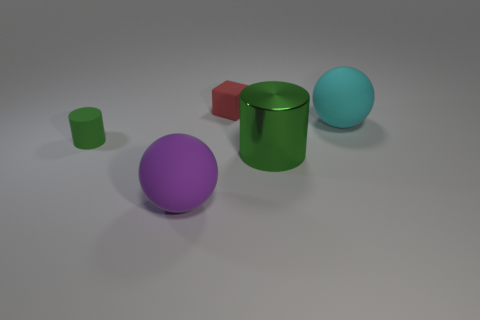Is the material of the tiny green cylinder the same as the big green thing?
Offer a very short reply. No. What number of blocks are either large gray rubber things or cyan things?
Offer a very short reply. 0. There is a green object that is to the left of the small object to the right of the rubber sphere that is to the left of the red thing; what size is it?
Your answer should be very brief. Small. The other object that is the same shape as the green matte object is what size?
Ensure brevity in your answer.  Large. How many large cyan matte things are in front of the small green rubber cylinder?
Your answer should be very brief. 0. There is a rubber sphere in front of the small green rubber thing; does it have the same color as the metal object?
Provide a succinct answer. No. What number of blue things are cubes or big cylinders?
Make the answer very short. 0. There is a tiny object that is behind the green cylinder left of the large purple rubber thing; what color is it?
Offer a terse response. Red. What material is the tiny cylinder that is the same color as the metal thing?
Your response must be concise. Rubber. What color is the large rubber object that is left of the green metallic cylinder?
Your answer should be compact. Purple. 